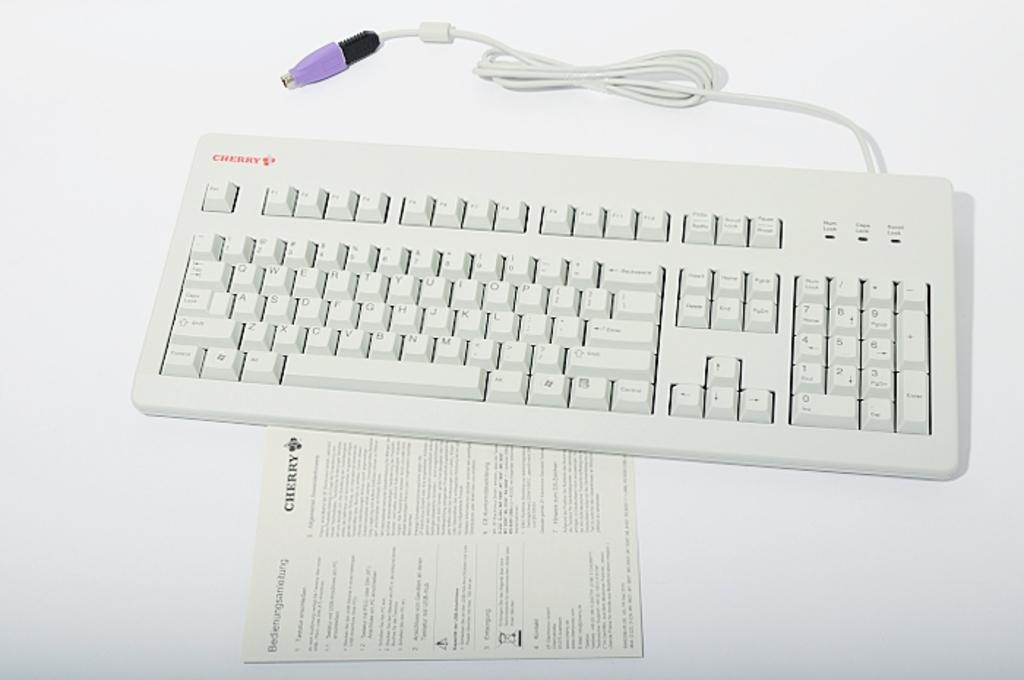Provide a one-sentence caption for the provided image. A white computer keyboard has the word Cherry written on the instructions and the product. 